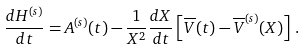Convert formula to latex. <formula><loc_0><loc_0><loc_500><loc_500>\frac { d H ^ { ( s ) } } { d t } = A ^ { ( s ) } ( t ) - \frac { 1 } { X ^ { 2 } } \frac { d X } { d t } \left [ \overline { V } ( t ) - \overline { V } ^ { ( s ) } ( X ) \right ] \, .</formula> 